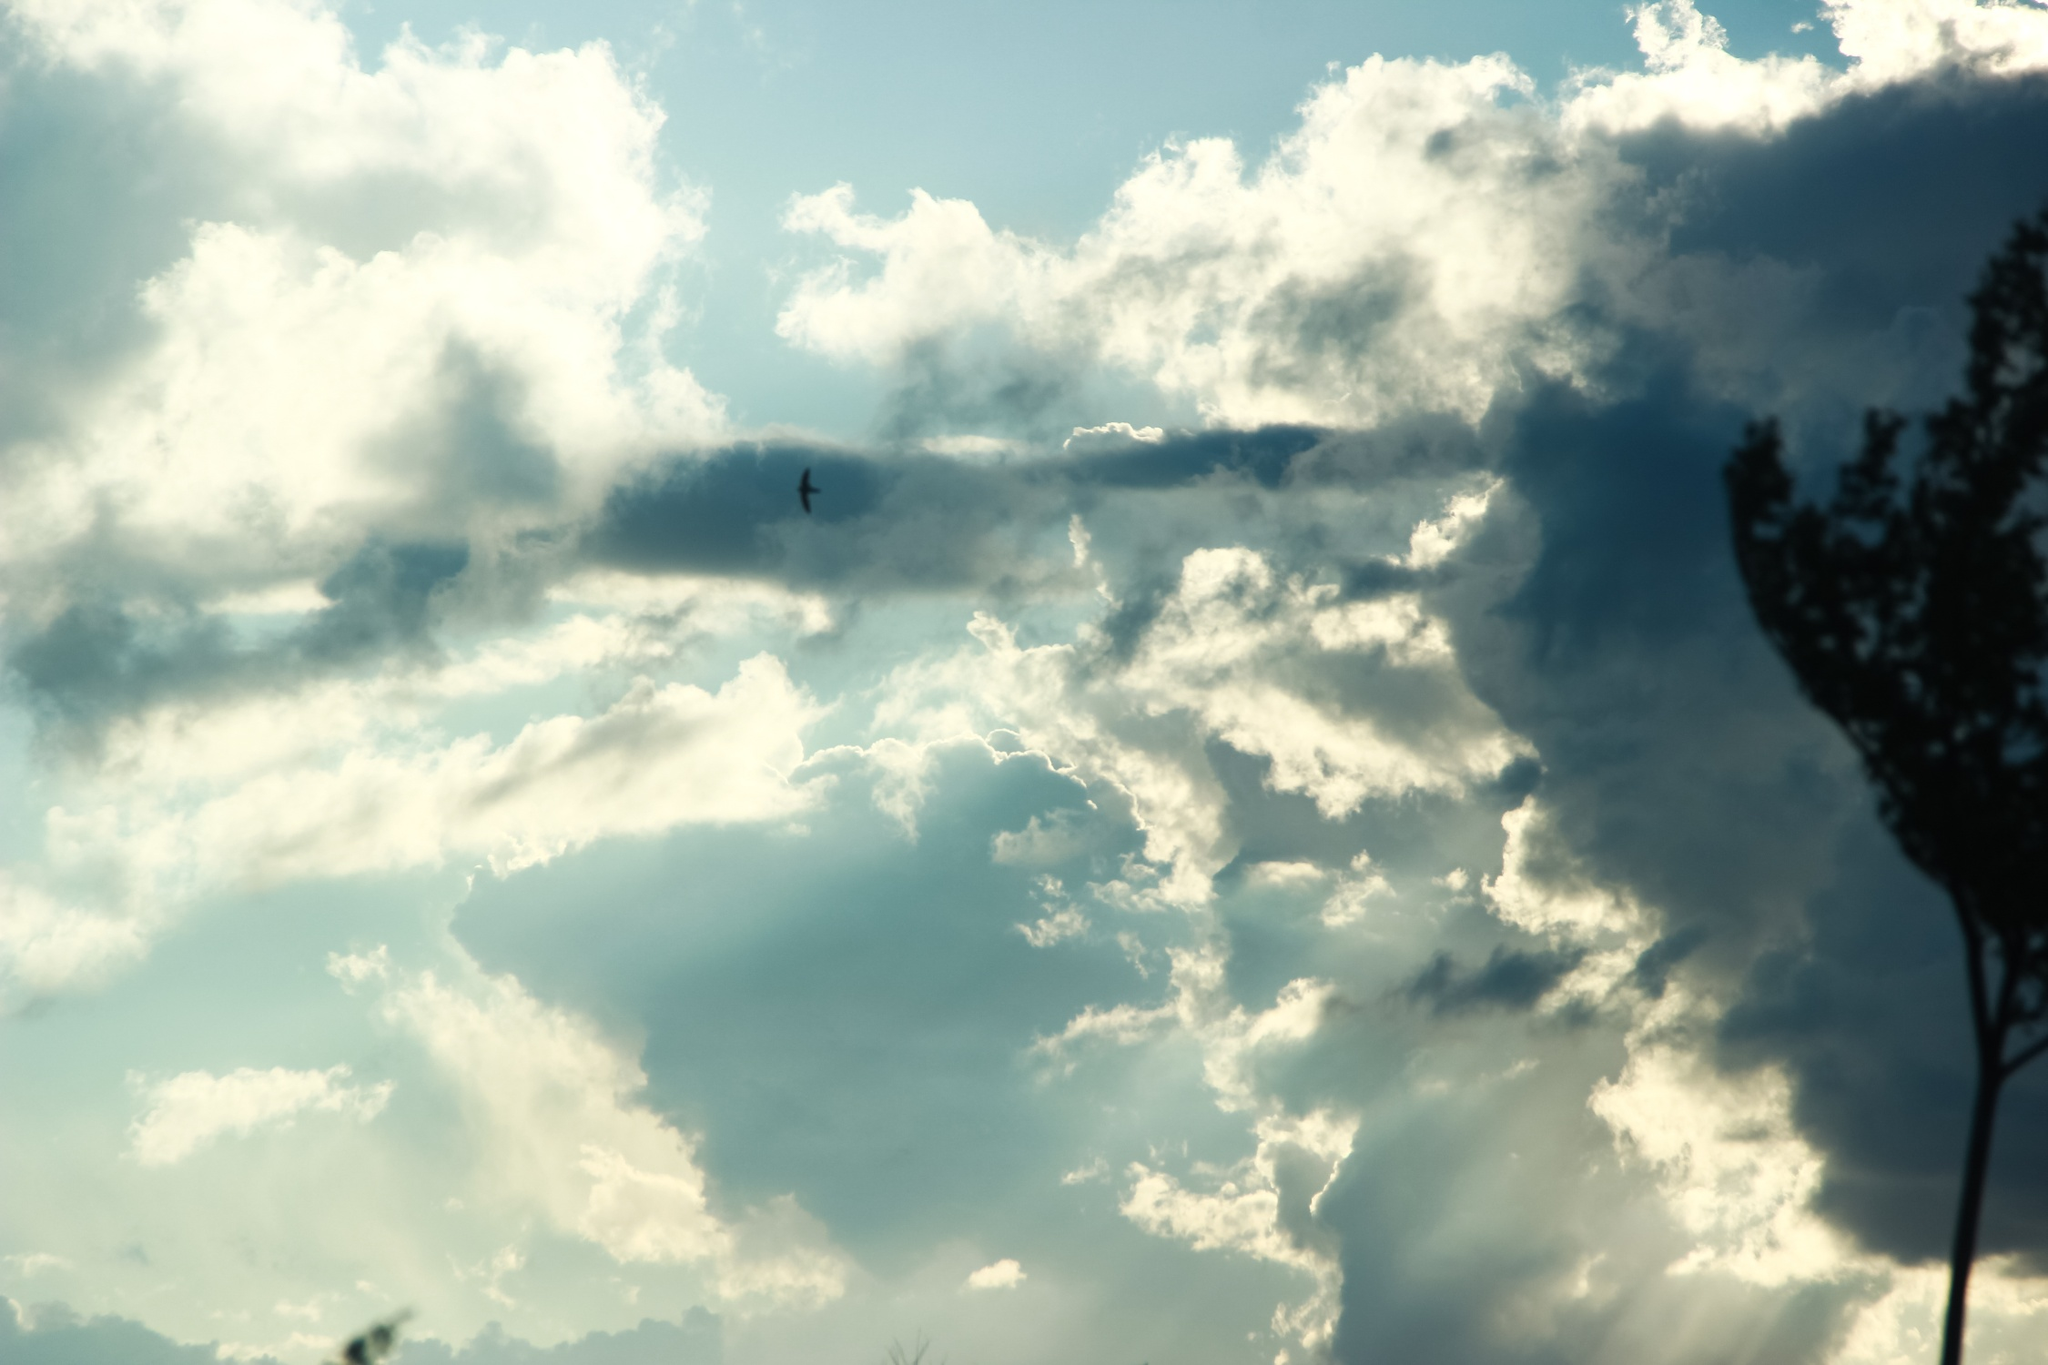Conjure a fantastical story inspired by this image. Once upon a time in a land where the sky met the earth in boundless harmony, there thrived a magical tree known as the Sentinel of Whispers. This tree, with branches reaching outward like ancient fingers, was believed to be the guardian of the skies. Legends whispered that the clouds were more than mere collections of vapor; they were the resting spirits of fallen stars. One day, a sparrow named Zephyr, who possessed a heart of gold, set out to find the Lost Wing—a mythical feather said to grant eternal freedom. Guided by the Sentinel of Whispers, Zephyr traversed turbulent skies and serene horizons alike. Along his journey, he encountered wise old clouds who shared tales of old-world magic and the timeless dance of the wind. With each flutter of his wings, Zephyr inched closer to the Lost Wing, not knowing that the journey itself was the true embodiment of what he sought. Zephyr's story became one with the skies, a tale of boundless aspirations and the ceaseless quest for freedom. 